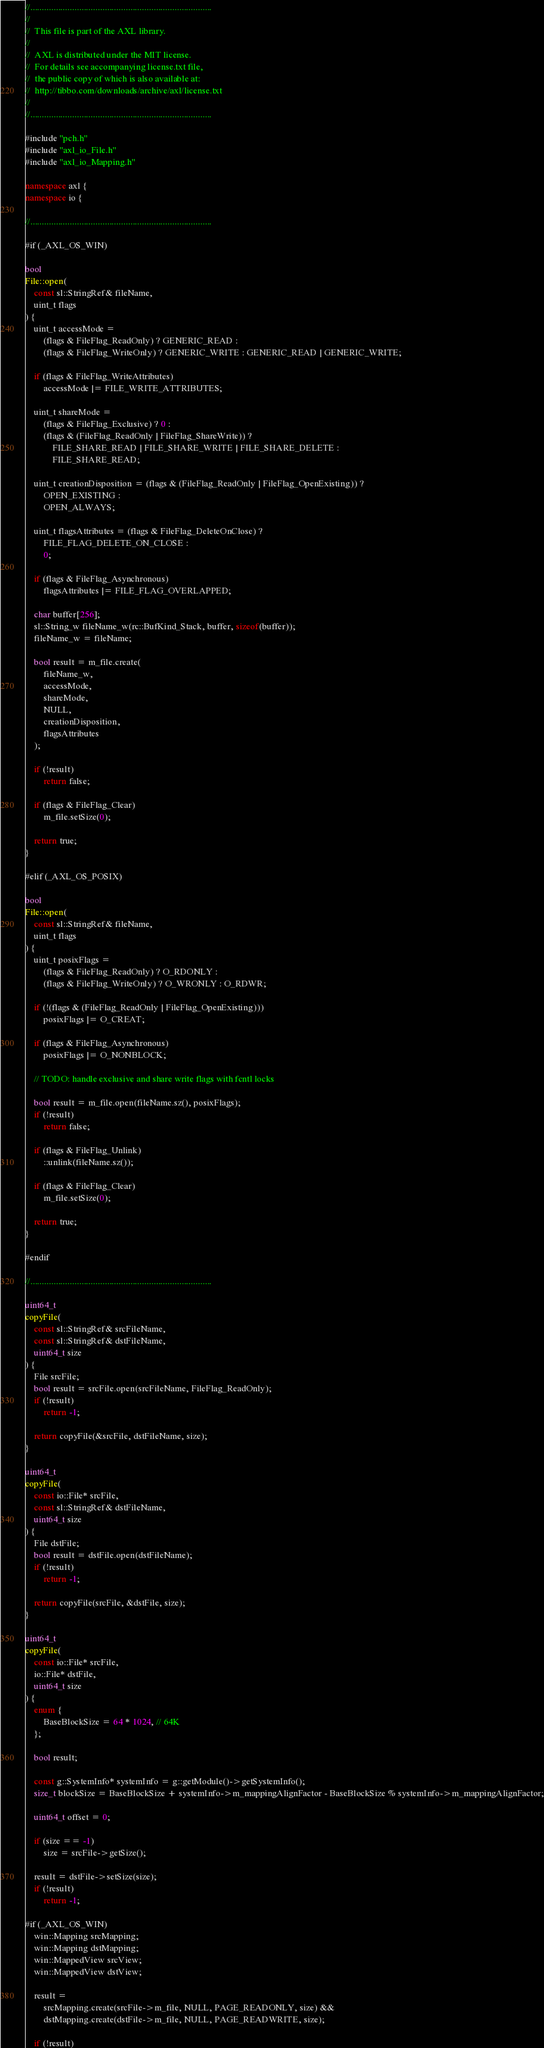Convert code to text. <code><loc_0><loc_0><loc_500><loc_500><_C++_>//..............................................................................
//
//  This file is part of the AXL library.
//
//  AXL is distributed under the MIT license.
//  For details see accompanying license.txt file,
//  the public copy of which is also available at:
//  http://tibbo.com/downloads/archive/axl/license.txt
//
//..............................................................................

#include "pch.h"
#include "axl_io_File.h"
#include "axl_io_Mapping.h"

namespace axl {
namespace io {

//..............................................................................

#if (_AXL_OS_WIN)

bool
File::open(
	const sl::StringRef& fileName,
	uint_t flags
) {
	uint_t accessMode =
		(flags & FileFlag_ReadOnly) ? GENERIC_READ :
		(flags & FileFlag_WriteOnly) ? GENERIC_WRITE : GENERIC_READ | GENERIC_WRITE;

	if (flags & FileFlag_WriteAttributes)
		accessMode |= FILE_WRITE_ATTRIBUTES;

	uint_t shareMode =
		(flags & FileFlag_Exclusive) ? 0 :
		(flags & (FileFlag_ReadOnly | FileFlag_ShareWrite)) ?
			FILE_SHARE_READ | FILE_SHARE_WRITE | FILE_SHARE_DELETE :
			FILE_SHARE_READ;

	uint_t creationDisposition = (flags & (FileFlag_ReadOnly | FileFlag_OpenExisting)) ?
		OPEN_EXISTING :
		OPEN_ALWAYS;

	uint_t flagsAttributes = (flags & FileFlag_DeleteOnClose) ?
		FILE_FLAG_DELETE_ON_CLOSE :
		0;

	if (flags & FileFlag_Asynchronous)
		flagsAttributes |= FILE_FLAG_OVERLAPPED;

	char buffer[256];
	sl::String_w fileName_w(rc::BufKind_Stack, buffer, sizeof(buffer));
	fileName_w = fileName;

	bool result = m_file.create(
		fileName_w,
		accessMode,
		shareMode,
		NULL,
		creationDisposition,
		flagsAttributes
	);

	if (!result)
		return false;

	if (flags & FileFlag_Clear)
		m_file.setSize(0);

	return true;
}

#elif (_AXL_OS_POSIX)

bool
File::open(
	const sl::StringRef& fileName,
	uint_t flags
) {
	uint_t posixFlags =
		(flags & FileFlag_ReadOnly) ? O_RDONLY :
		(flags & FileFlag_WriteOnly) ? O_WRONLY : O_RDWR;

	if (!(flags & (FileFlag_ReadOnly | FileFlag_OpenExisting)))
		posixFlags |= O_CREAT;

	if (flags & FileFlag_Asynchronous)
		posixFlags |= O_NONBLOCK;

	// TODO: handle exclusive and share write flags with fcntl locks

	bool result = m_file.open(fileName.sz(), posixFlags);
	if (!result)
		return false;

	if (flags & FileFlag_Unlink)
		::unlink(fileName.sz());

	if (flags & FileFlag_Clear)
		m_file.setSize(0);

	return true;
}

#endif

//..............................................................................

uint64_t
copyFile(
	const sl::StringRef& srcFileName,
	const sl::StringRef& dstFileName,
	uint64_t size
) {
	File srcFile;
	bool result = srcFile.open(srcFileName, FileFlag_ReadOnly);
	if (!result)
		return -1;

	return copyFile(&srcFile, dstFileName, size);
}

uint64_t
copyFile(
	const io::File* srcFile,
	const sl::StringRef& dstFileName,
	uint64_t size
) {
	File dstFile;
	bool result = dstFile.open(dstFileName);
	if (!result)
		return -1;

	return copyFile(srcFile, &dstFile, size);
}

uint64_t
copyFile(
	const io::File* srcFile,
	io::File* dstFile,
	uint64_t size
) {
	enum {
		BaseBlockSize = 64 * 1024, // 64K
	};

	bool result;

	const g::SystemInfo* systemInfo = g::getModule()->getSystemInfo();
	size_t blockSize = BaseBlockSize + systemInfo->m_mappingAlignFactor - BaseBlockSize % systemInfo->m_mappingAlignFactor;

	uint64_t offset = 0;

	if (size == -1)
		size = srcFile->getSize();

	result = dstFile->setSize(size);
	if (!result)
		return -1;

#if (_AXL_OS_WIN)
	win::Mapping srcMapping;
	win::Mapping dstMapping;
	win::MappedView srcView;
	win::MappedView dstView;

	result =
		srcMapping.create(srcFile->m_file, NULL, PAGE_READONLY, size) &&
		dstMapping.create(dstFile->m_file, NULL, PAGE_READWRITE, size);

	if (!result)</code> 